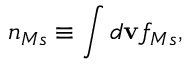Convert formula to latex. <formula><loc_0><loc_0><loc_500><loc_500>n _ { M s } \equiv \int d v f _ { M s } ,</formula> 